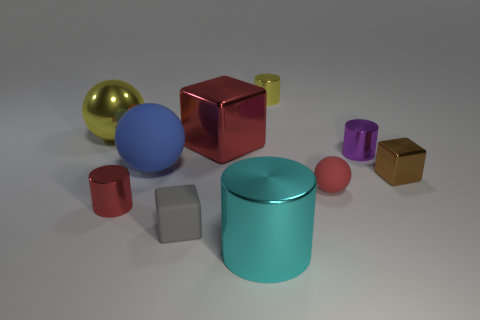There is a matte object that is the same color as the big shiny cube; what is its size?
Ensure brevity in your answer.  Small. Is the shape of the red thing behind the small brown metal thing the same as  the purple object?
Your response must be concise. No. Are there any other things that are the same material as the tiny brown cube?
Ensure brevity in your answer.  Yes. There is a blue thing; is its size the same as the red cylinder on the left side of the gray object?
Make the answer very short. No. How many other objects are there of the same color as the big shiny sphere?
Ensure brevity in your answer.  1. Are there any tiny rubber cubes on the right side of the yellow cylinder?
Make the answer very short. No. How many objects are either tiny blue cubes or tiny objects behind the brown object?
Offer a very short reply. 2. There is a big shiny thing that is behind the large red cube; are there any large objects that are to the right of it?
Your answer should be compact. Yes. There is a brown thing that is behind the matte ball right of the small object that is behind the big yellow sphere; what is its shape?
Keep it short and to the point. Cube. What color is the object that is in front of the brown metallic cube and on the left side of the small gray thing?
Keep it short and to the point. Red. 